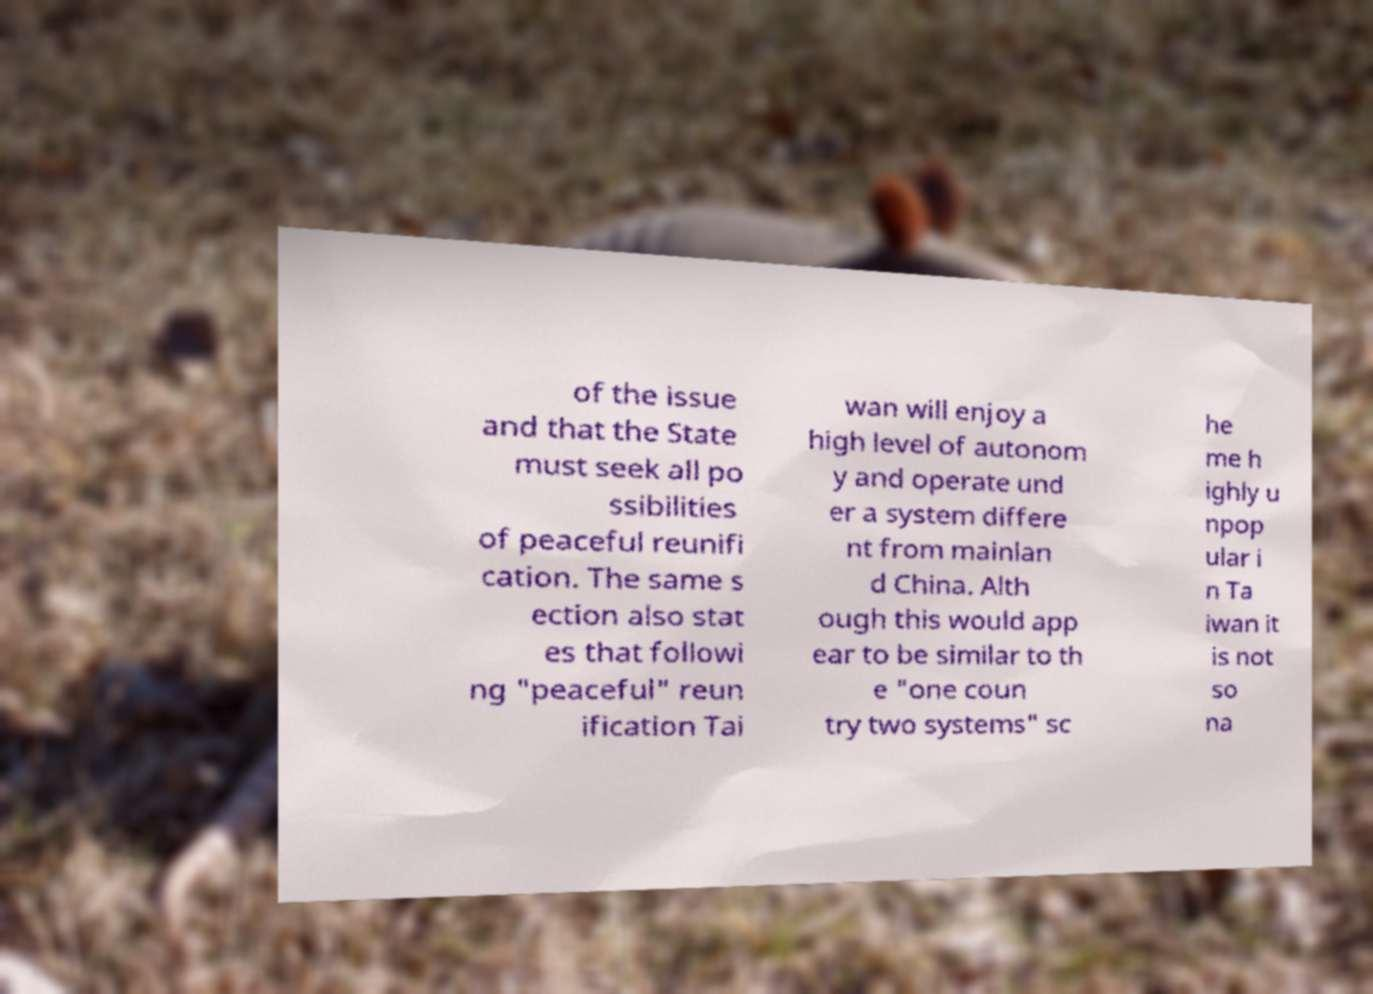Could you extract and type out the text from this image? of the issue and that the State must seek all po ssibilities of peaceful reunifi cation. The same s ection also stat es that followi ng "peaceful" reun ification Tai wan will enjoy a high level of autonom y and operate und er a system differe nt from mainlan d China. Alth ough this would app ear to be similar to th e "one coun try two systems" sc he me h ighly u npop ular i n Ta iwan it is not so na 